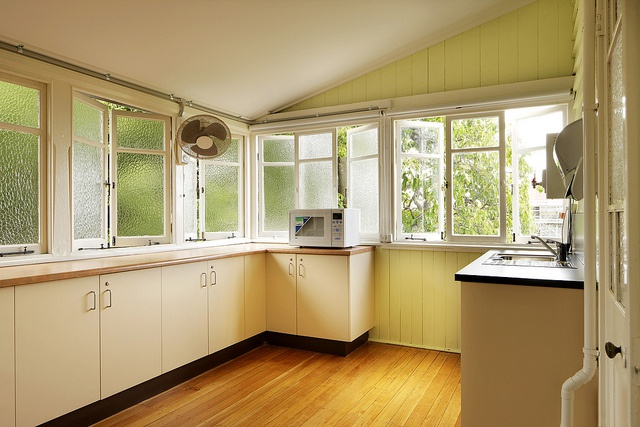Describe the objects in this image and their specific colors. I can see microwave in tan, lightgray, and gray tones and sink in tan, lightgray, darkgray, and gray tones in this image. 